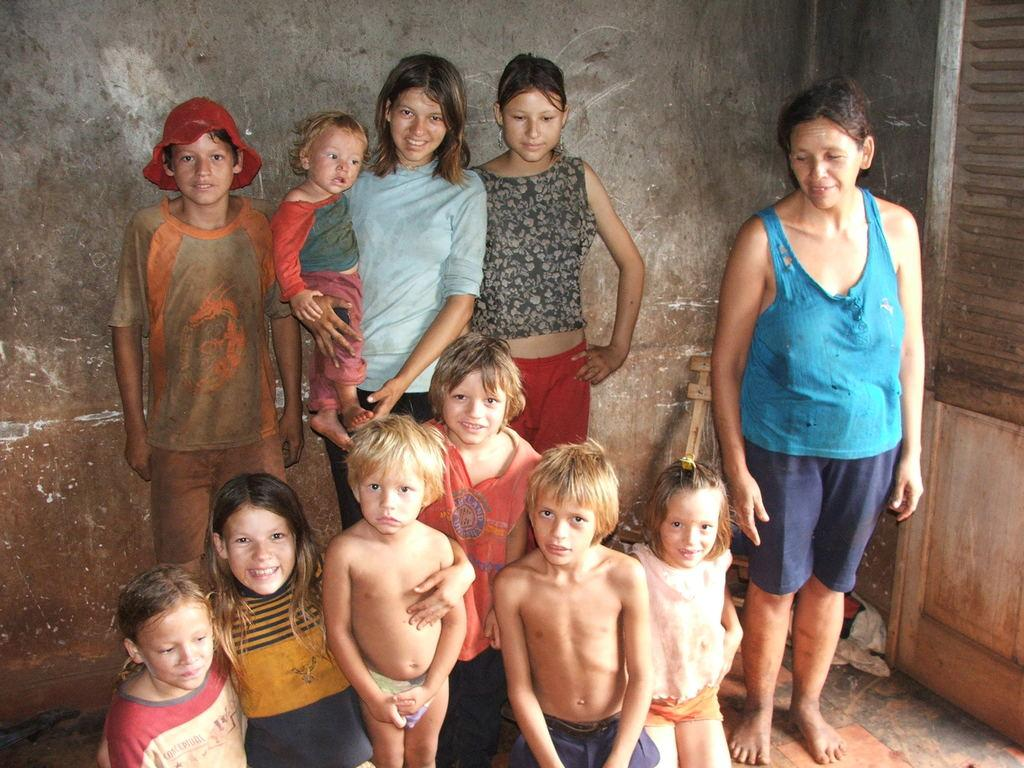What is the main subject of the image? The main subject of the image is a group of people. Can you describe the woman in the image? The woman is carrying a baby. What can be seen in the background of the image? There is a wall in the background of the image. How many wings can be seen on the baby in the image? There are no wings visible on the baby in the image. What type of star is present in the image? There is no star present in the image. 